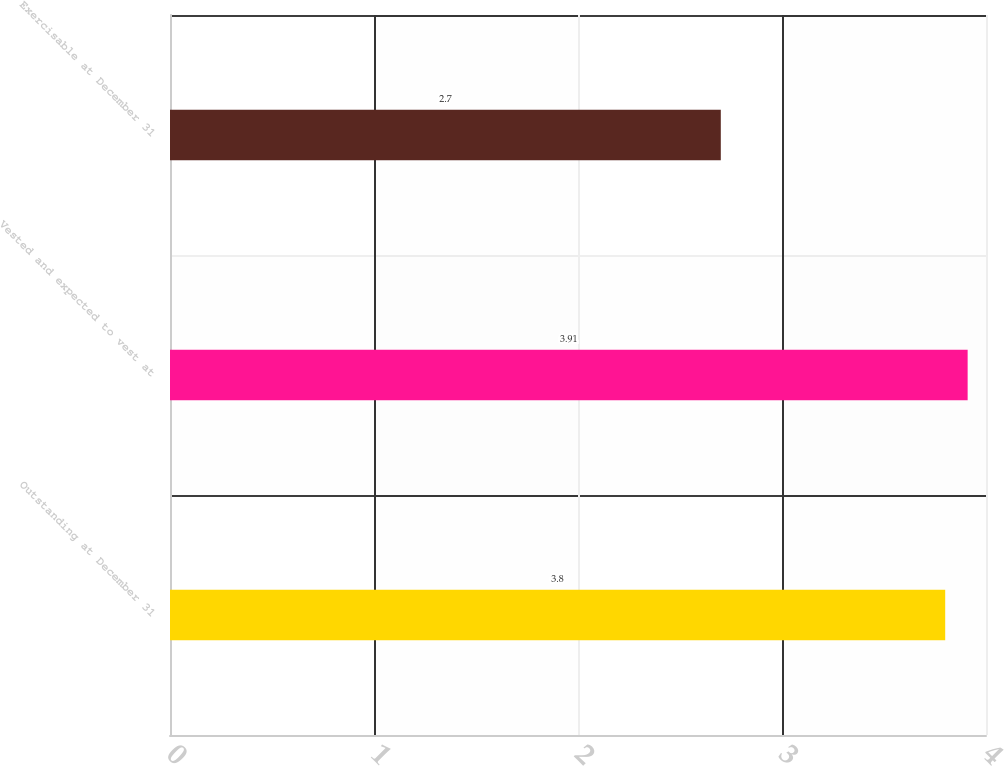Convert chart. <chart><loc_0><loc_0><loc_500><loc_500><bar_chart><fcel>Outstanding at December 31<fcel>Vested and expected to vest at<fcel>Exercisable at December 31<nl><fcel>3.8<fcel>3.91<fcel>2.7<nl></chart> 